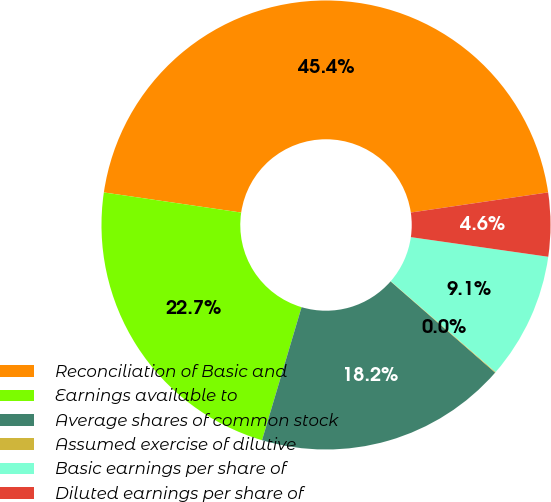Convert chart. <chart><loc_0><loc_0><loc_500><loc_500><pie_chart><fcel>Reconciliation of Basic and<fcel>Earnings available to<fcel>Average shares of common stock<fcel>Assumed exercise of dilutive<fcel>Basic earnings per share of<fcel>Diluted earnings per share of<nl><fcel>45.37%<fcel>22.72%<fcel>18.18%<fcel>0.05%<fcel>9.11%<fcel>4.58%<nl></chart> 